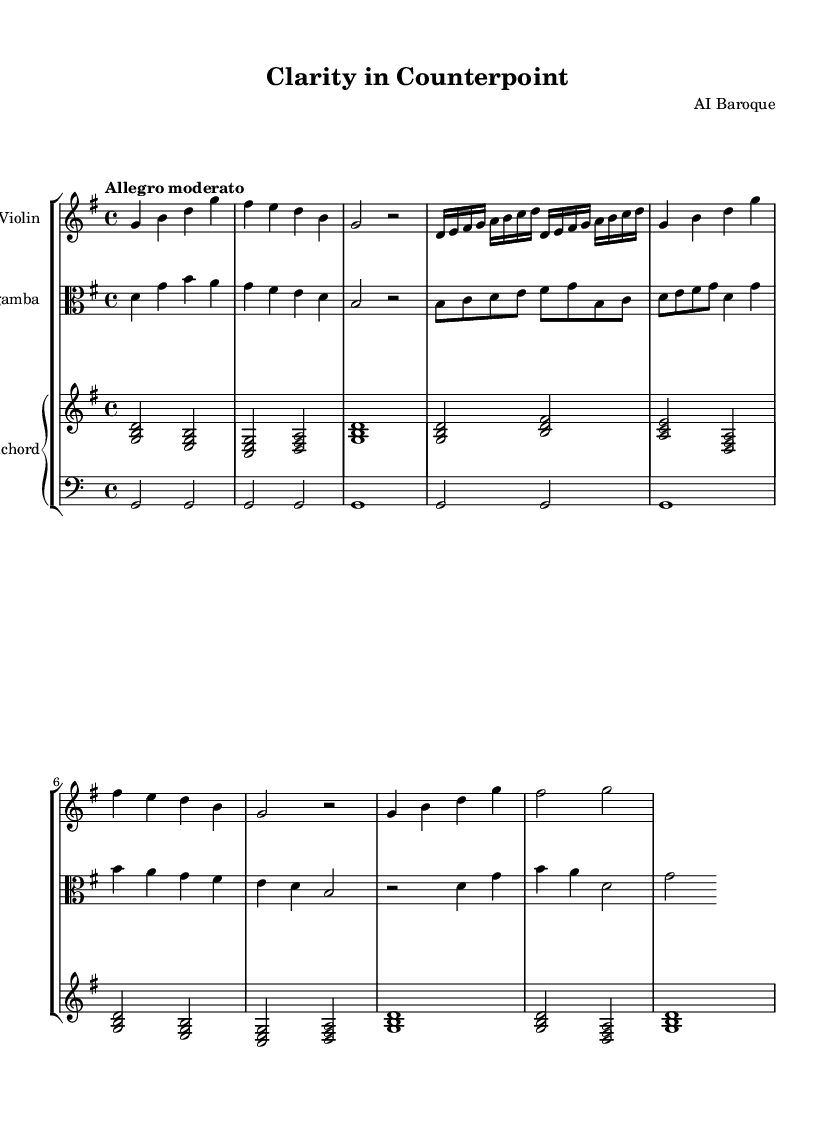What is the key signature of this music? The key signature is G major, which has one sharp (F#).
Answer: G major What is the time signature of this music? The time signature is 4/4, indicating four beats per measure.
Answer: 4/4 What is the tempo marking for this piece? The tempo marking is "Allegro moderato," indicating a moderately fast tempo.
Answer: Allegro moderato How many measures are in the A section? The A section consists of 4 measures, as indicated by the musical notation.
Answer: 4 Which instruments are featured in this composition? The composition features violin, viola da gamba, and harpsichord.
Answer: Violin, viola da gamba, and harpsichord How does the B section differ in note density compared to the A section? The B section has more rapid notes, including sixteenth notes, compared to the quarter note density in the A section.
Answer: More rapid notes What is the final cadence of the piece, indicating its closure? The final cadence is a G major chord, which resolves the harmony and concludes the piece.
Answer: G major chord 